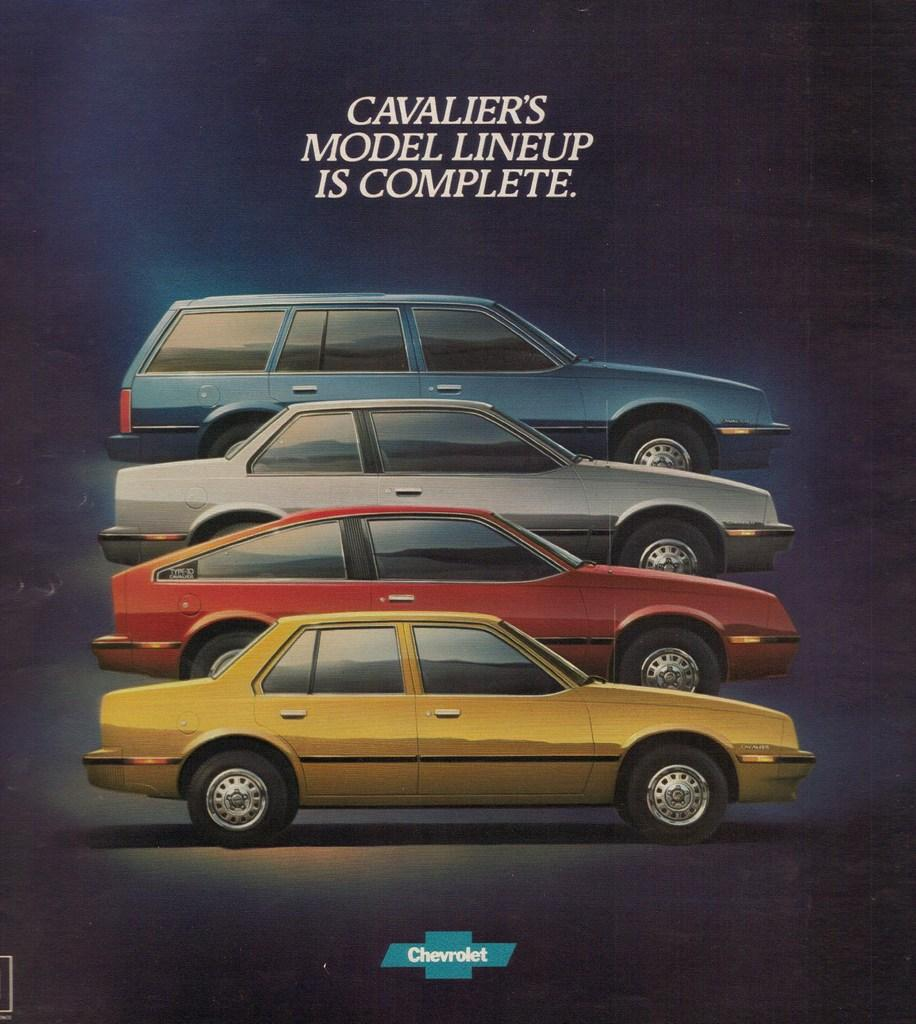How many cars are featured in the image? There are four colorful cars in the image. What type of publication might this image be from? The image is a magazine cover photo. What message is conveyed by the text on the top of the image? The text "Model lineup is completed" suggests that the cars in the image are part of a complete model lineup. Where are the kittens playing on the coast in the image? There are no kittens or coast present in the image; it features four colorful cars and the text "Model lineup is completed." 